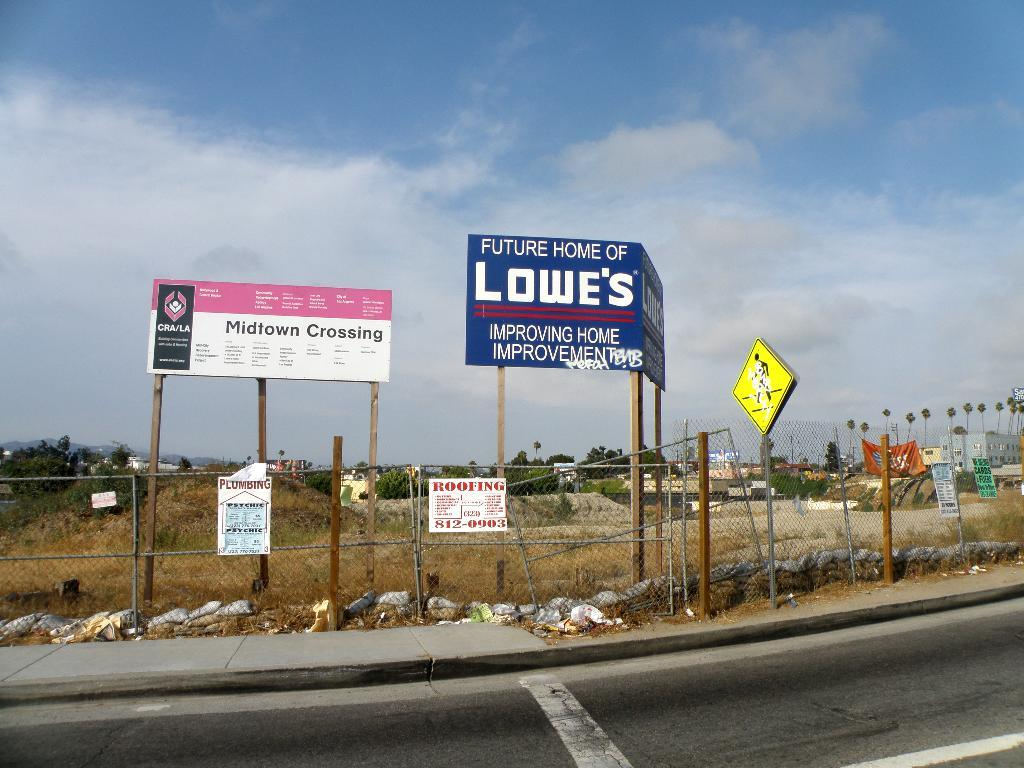<image>
Share a concise interpretation of the image provided. A construction site advertising the future home of a Lowes store. 